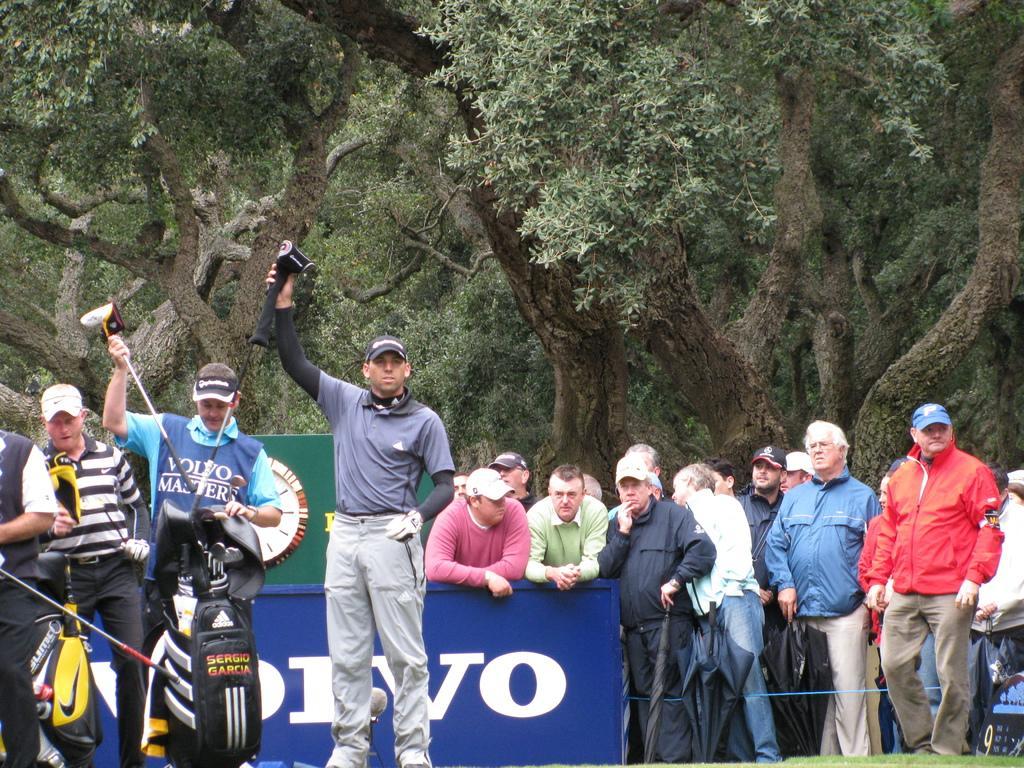Please provide a concise description of this image. In the picture I can see four persons standing and holding a stick in their hands in the left corner and there are few other people behind them and there are trees in the background. 